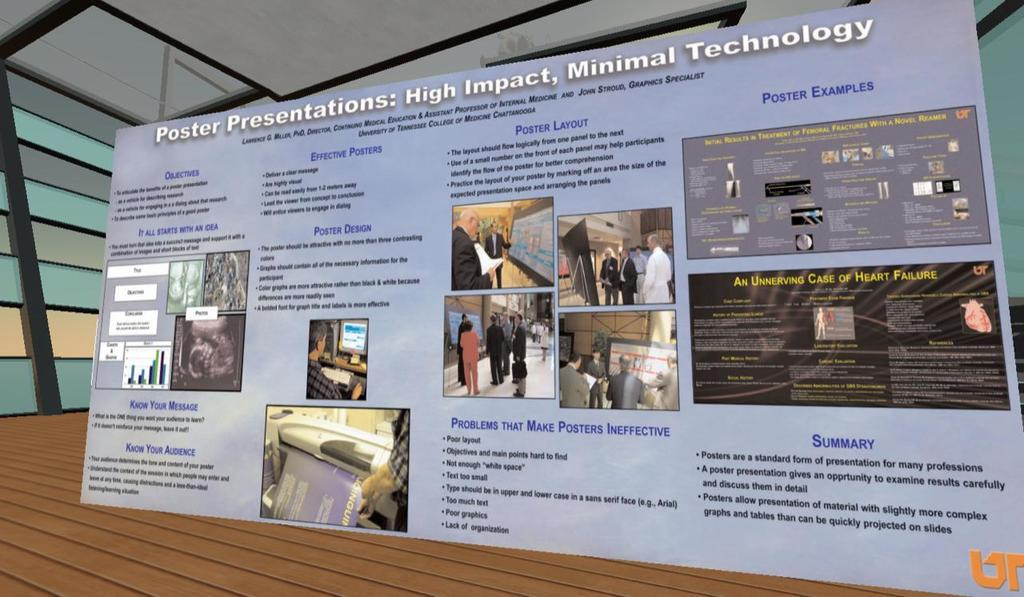<image>
Describe the image concisely. A wall size sign that says "Poster Presentations: High Impact, Minimal Technology" 